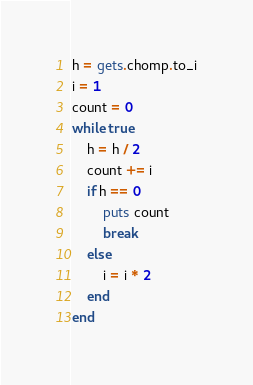Convert code to text. <code><loc_0><loc_0><loc_500><loc_500><_Ruby_>h = gets.chomp.to_i
i = 1
count = 0
while true
    h = h / 2
    count += i
    if h == 0
        puts count
        break
    else
        i = i * 2
    end
end</code> 